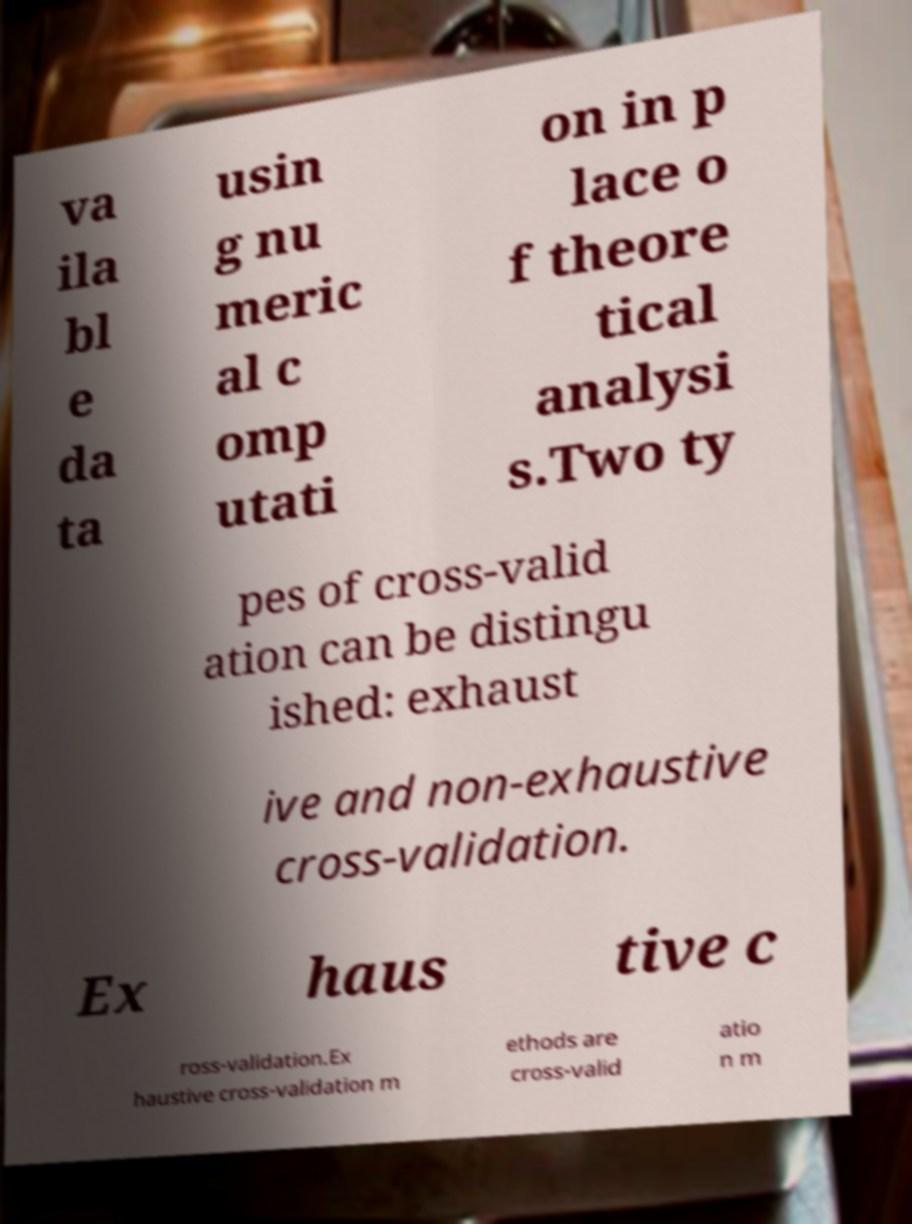There's text embedded in this image that I need extracted. Can you transcribe it verbatim? va ila bl e da ta usin g nu meric al c omp utati on in p lace o f theore tical analysi s.Two ty pes of cross-valid ation can be distingu ished: exhaust ive and non-exhaustive cross-validation. Ex haus tive c ross-validation.Ex haustive cross-validation m ethods are cross-valid atio n m 